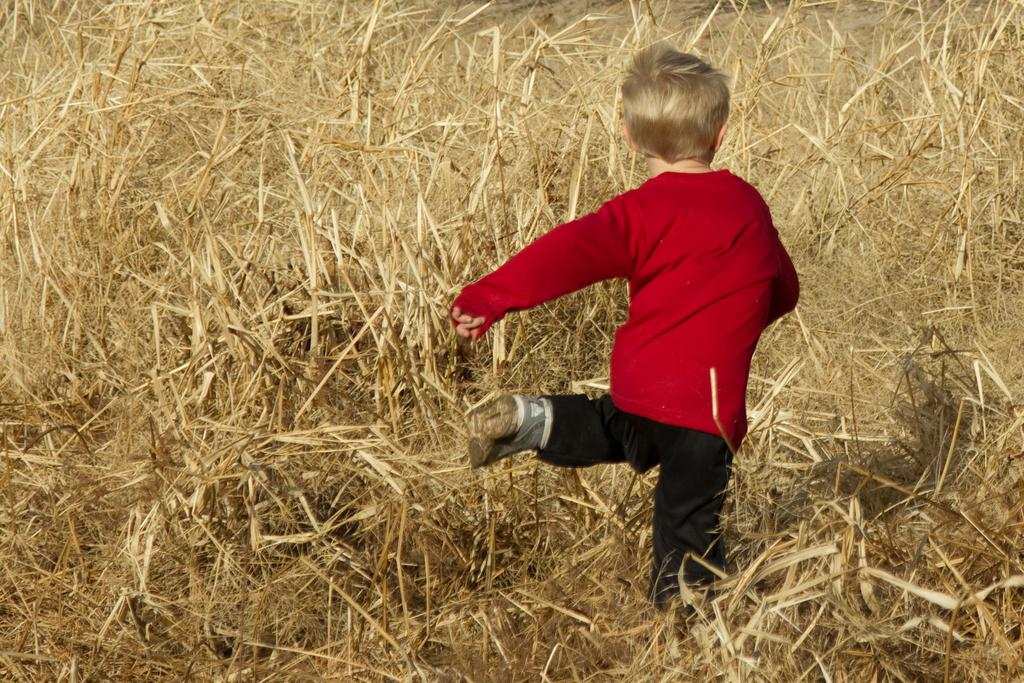Who is the main subject in the picture? There is a boy in the picture. What is the boy wearing on his upper body? The boy is wearing a red t-shirt. What is the boy wearing on his lower body? The boy is wearing black pants. What type of footwear is the boy wearing? The boy is wearing shoes. What type of terrain is visible in the picture? There is grass visible in the picture. How far away are the toys from the boy in the picture? There are no toys present in the image, so it is not possible to determine their distance from the boy. 